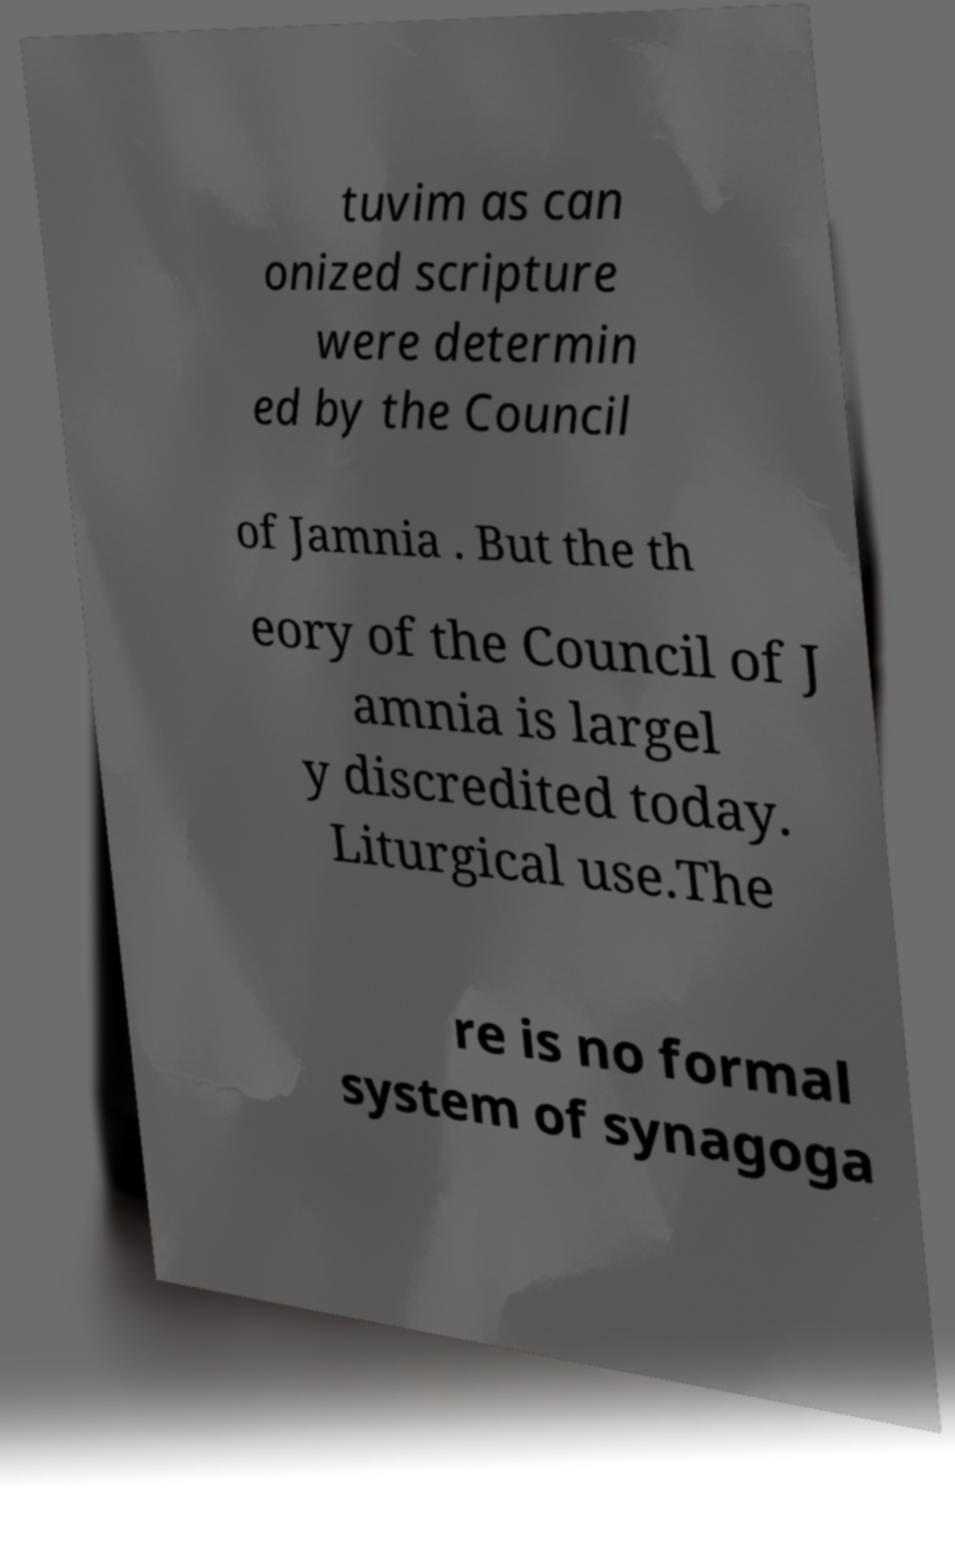Can you accurately transcribe the text from the provided image for me? tuvim as can onized scripture were determin ed by the Council of Jamnia . But the th eory of the Council of J amnia is largel y discredited today. Liturgical use.The re is no formal system of synagoga 